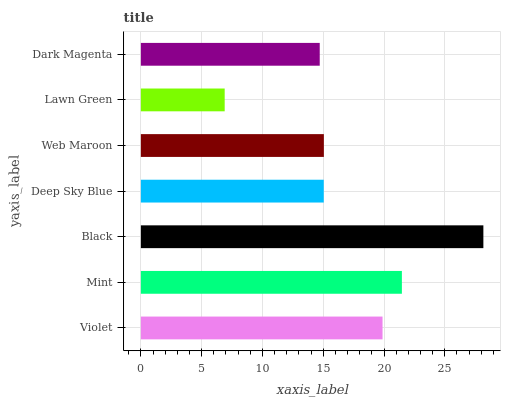Is Lawn Green the minimum?
Answer yes or no. Yes. Is Black the maximum?
Answer yes or no. Yes. Is Mint the minimum?
Answer yes or no. No. Is Mint the maximum?
Answer yes or no. No. Is Mint greater than Violet?
Answer yes or no. Yes. Is Violet less than Mint?
Answer yes or no. Yes. Is Violet greater than Mint?
Answer yes or no. No. Is Mint less than Violet?
Answer yes or no. No. Is Web Maroon the high median?
Answer yes or no. Yes. Is Web Maroon the low median?
Answer yes or no. Yes. Is Mint the high median?
Answer yes or no. No. Is Lawn Green the low median?
Answer yes or no. No. 